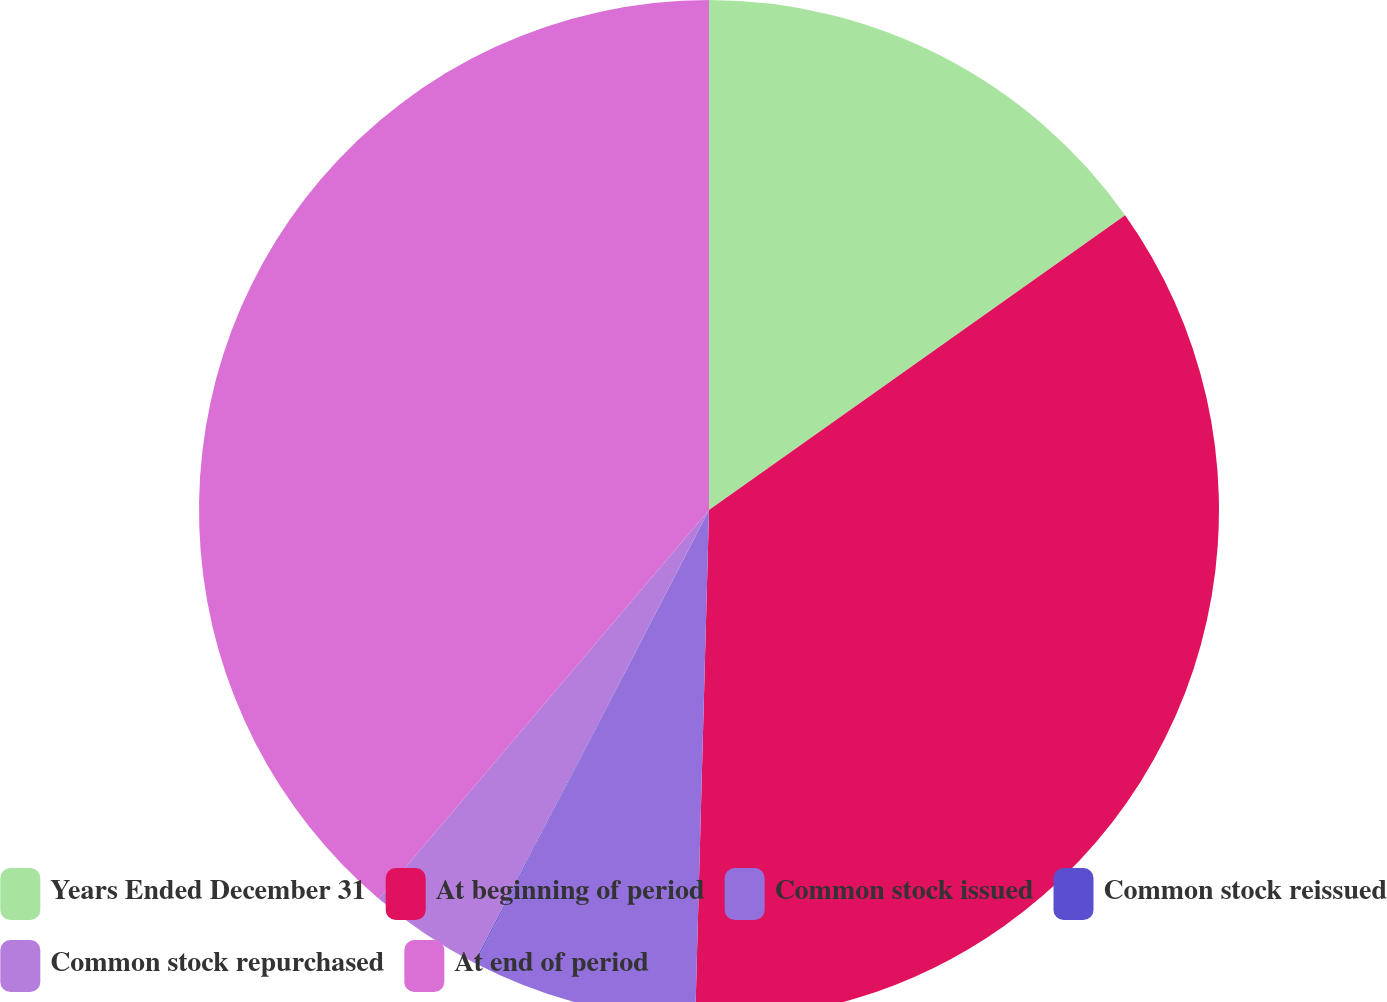<chart> <loc_0><loc_0><loc_500><loc_500><pie_chart><fcel>Years Ended December 31<fcel>At beginning of period<fcel>Common stock issued<fcel>Common stock reissued<fcel>Common stock repurchased<fcel>At end of period<nl><fcel>15.19%<fcel>35.24%<fcel>7.15%<fcel>0.04%<fcel>3.59%<fcel>38.79%<nl></chart> 